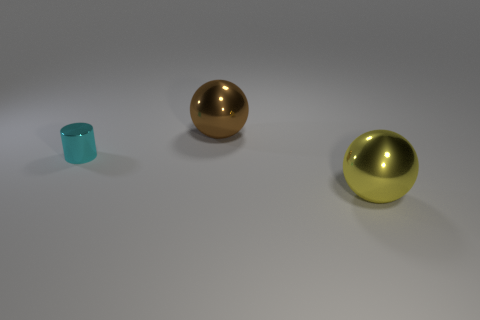Do the metallic sphere in front of the tiny cyan metallic cylinder and the shiny sphere that is left of the yellow shiny object have the same size?
Give a very brief answer. Yes. What is the size of the sphere that is in front of the large thing that is behind the yellow metal object?
Keep it short and to the point. Large. What is the thing that is right of the cyan metal object and to the left of the yellow sphere made of?
Ensure brevity in your answer.  Metal. What is the color of the tiny cylinder?
Ensure brevity in your answer.  Cyan. Is there anything else that has the same material as the cylinder?
Make the answer very short. Yes. What is the shape of the tiny cyan metallic object that is on the left side of the brown object?
Ensure brevity in your answer.  Cylinder. There is a large sphere that is behind the big object that is in front of the tiny cyan metal cylinder; are there any brown balls that are on the right side of it?
Provide a short and direct response. No. Is there anything else that has the same shape as the cyan object?
Provide a short and direct response. No. Are there any cyan shiny cylinders?
Your response must be concise. Yes. Does the big sphere in front of the cyan cylinder have the same material as the cyan object that is to the left of the brown object?
Provide a short and direct response. Yes. 